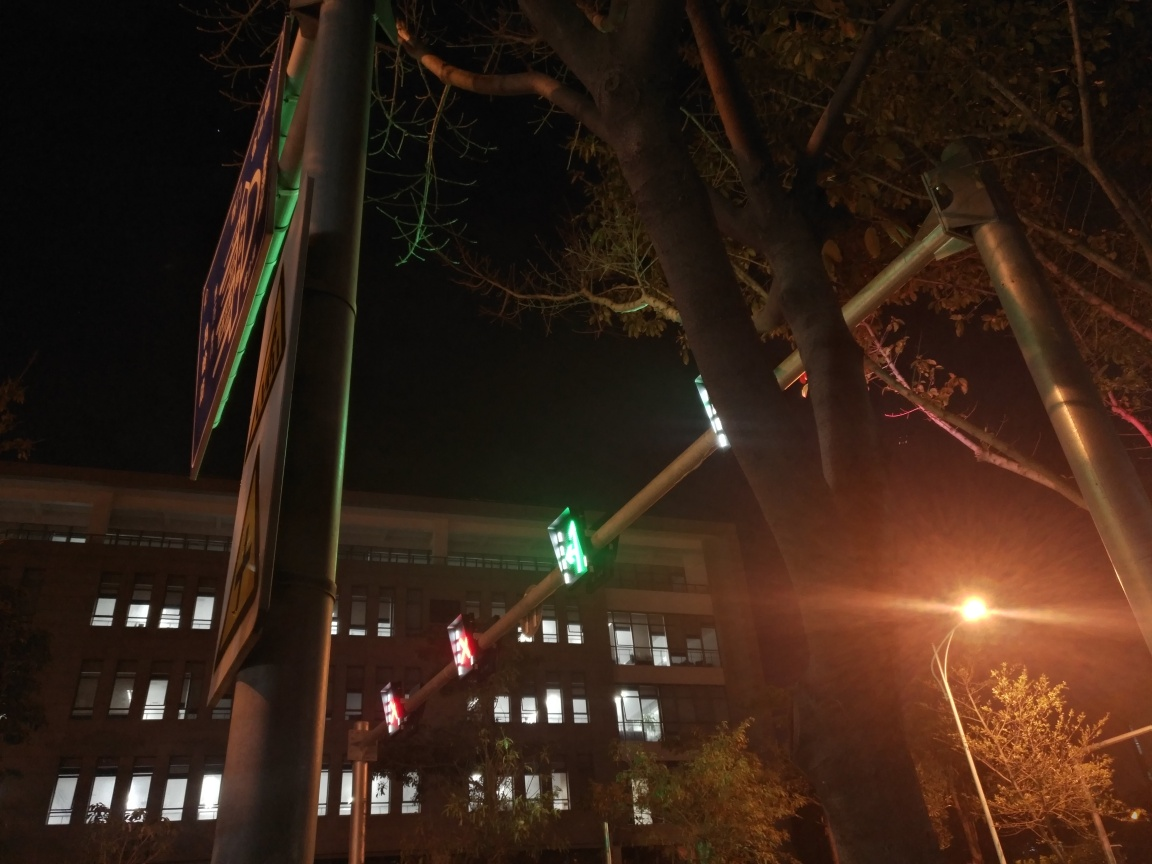What time of day does this image appear to have been taken? The photo seems to have been taken at night, as indicated by the artificial lighting from the street lights and the absence of natural daylight. 